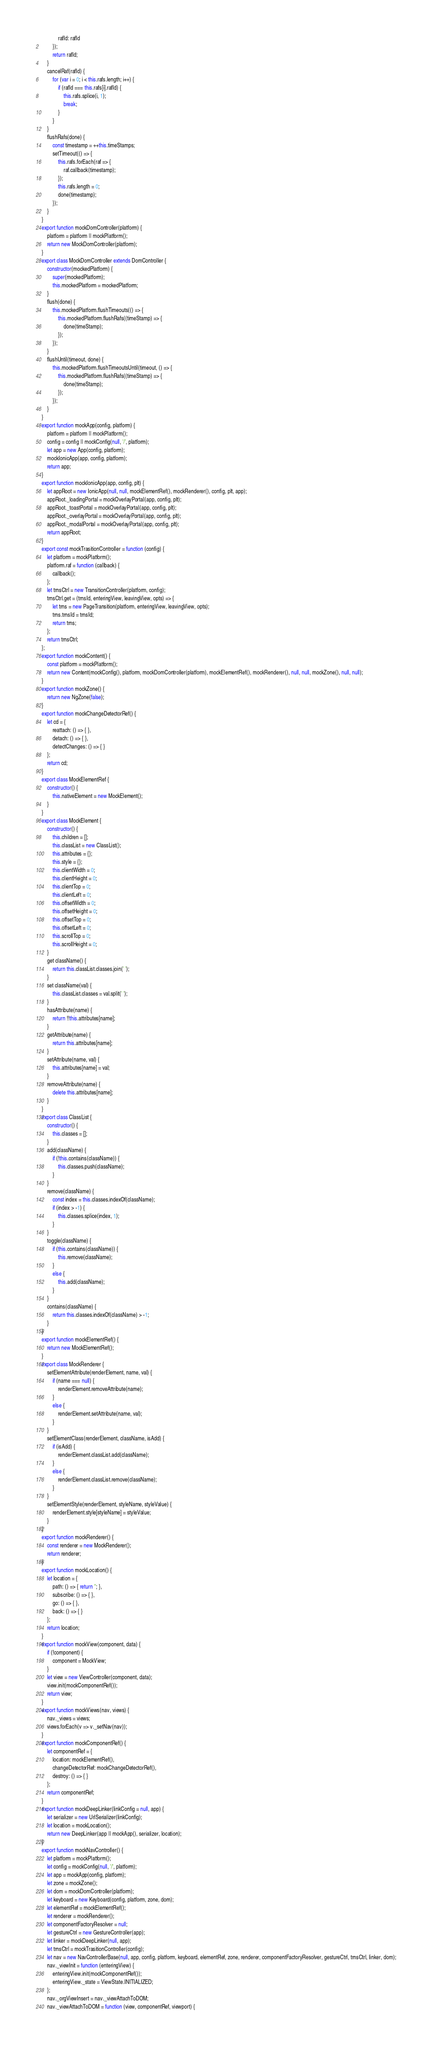<code> <loc_0><loc_0><loc_500><loc_500><_JavaScript_>            rafId: rafId
        });
        return rafId;
    }
    cancelRaf(rafId) {
        for (var i = 0; i < this.rafs.length; i++) {
            if (rafId === this.rafs[i].rafId) {
                this.rafs.splice(i, 1);
                break;
            }
        }
    }
    flushRafs(done) {
        const timestamp = ++this.timeStamps;
        setTimeout(() => {
            this.rafs.forEach(raf => {
                raf.callback(timestamp);
            });
            this.rafs.length = 0;
            done(timestamp);
        });
    }
}
export function mockDomController(platform) {
    platform = platform || mockPlatform();
    return new MockDomController(platform);
}
export class MockDomController extends DomController {
    constructor(mockedPlatform) {
        super(mockedPlatform);
        this.mockedPlatform = mockedPlatform;
    }
    flush(done) {
        this.mockedPlatform.flushTimeouts(() => {
            this.mockedPlatform.flushRafs((timeStamp) => {
                done(timeStamp);
            });
        });
    }
    flushUntil(timeout, done) {
        this.mockedPlatform.flushTimeoutsUntil(timeout, () => {
            this.mockedPlatform.flushRafs((timeStamp) => {
                done(timeStamp);
            });
        });
    }
}
export function mockApp(config, platform) {
    platform = platform || mockPlatform();
    config = config || mockConfig(null, '/', platform);
    let app = new App(config, platform);
    mockIonicApp(app, config, platform);
    return app;
}
export function mockIonicApp(app, config, plt) {
    let appRoot = new IonicApp(null, null, mockElementRef(), mockRenderer(), config, plt, app);
    appRoot._loadingPortal = mockOverlayPortal(app, config, plt);
    appRoot._toastPortal = mockOverlayPortal(app, config, plt);
    appRoot._overlayPortal = mockOverlayPortal(app, config, plt);
    appRoot._modalPortal = mockOverlayPortal(app, config, plt);
    return appRoot;
}
export const mockTrasitionController = function (config) {
    let platform = mockPlatform();
    platform.raf = function (callback) {
        callback();
    };
    let trnsCtrl = new TransitionController(platform, config);
    trnsCtrl.get = (trnsId, enteringView, leavingView, opts) => {
        let trns = new PageTransition(platform, enteringView, leavingView, opts);
        trns.trnsId = trnsId;
        return trns;
    };
    return trnsCtrl;
};
export function mockContent() {
    const platform = mockPlatform();
    return new Content(mockConfig(), platform, mockDomController(platform), mockElementRef(), mockRenderer(), null, null, mockZone(), null, null);
}
export function mockZone() {
    return new NgZone(false);
}
export function mockChangeDetectorRef() {
    let cd = {
        reattach: () => { },
        detach: () => { },
        detectChanges: () => { }
    };
    return cd;
}
export class MockElementRef {
    constructor() {
        this.nativeElement = new MockElement();
    }
}
export class MockElement {
    constructor() {
        this.children = [];
        this.classList = new ClassList();
        this.attributes = {};
        this.style = {};
        this.clientWidth = 0;
        this.clientHeight = 0;
        this.clientTop = 0;
        this.clientLeft = 0;
        this.offsetWidth = 0;
        this.offsetHeight = 0;
        this.offsetTop = 0;
        this.offsetLeft = 0;
        this.scrollTop = 0;
        this.scrollHeight = 0;
    }
    get className() {
        return this.classList.classes.join(' ');
    }
    set className(val) {
        this.classList.classes = val.split(' ');
    }
    hasAttribute(name) {
        return !!this.attributes[name];
    }
    getAttribute(name) {
        return this.attributes[name];
    }
    setAttribute(name, val) {
        this.attributes[name] = val;
    }
    removeAttribute(name) {
        delete this.attributes[name];
    }
}
export class ClassList {
    constructor() {
        this.classes = [];
    }
    add(className) {
        if (!this.contains(className)) {
            this.classes.push(className);
        }
    }
    remove(className) {
        const index = this.classes.indexOf(className);
        if (index > -1) {
            this.classes.splice(index, 1);
        }
    }
    toggle(className) {
        if (this.contains(className)) {
            this.remove(className);
        }
        else {
            this.add(className);
        }
    }
    contains(className) {
        return this.classes.indexOf(className) > -1;
    }
}
export function mockElementRef() {
    return new MockElementRef();
}
export class MockRenderer {
    setElementAttribute(renderElement, name, val) {
        if (name === null) {
            renderElement.removeAttribute(name);
        }
        else {
            renderElement.setAttribute(name, val);
        }
    }
    setElementClass(renderElement, className, isAdd) {
        if (isAdd) {
            renderElement.classList.add(className);
        }
        else {
            renderElement.classList.remove(className);
        }
    }
    setElementStyle(renderElement, styleName, styleValue) {
        renderElement.style[styleName] = styleValue;
    }
}
export function mockRenderer() {
    const renderer = new MockRenderer();
    return renderer;
}
export function mockLocation() {
    let location = {
        path: () => { return ''; },
        subscribe: () => { },
        go: () => { },
        back: () => { }
    };
    return location;
}
export function mockView(component, data) {
    if (!component) {
        component = MockView;
    }
    let view = new ViewController(component, data);
    view.init(mockComponentRef());
    return view;
}
export function mockViews(nav, views) {
    nav._views = views;
    views.forEach(v => v._setNav(nav));
}
export function mockComponentRef() {
    let componentRef = {
        location: mockElementRef(),
        changeDetectorRef: mockChangeDetectorRef(),
        destroy: () => { }
    };
    return componentRef;
}
export function mockDeepLinker(linkConfig = null, app) {
    let serializer = new UrlSerializer(linkConfig);
    let location = mockLocation();
    return new DeepLinker(app || mockApp(), serializer, location);
}
export function mockNavController() {
    let platform = mockPlatform();
    let config = mockConfig(null, '/', platform);
    let app = mockApp(config, platform);
    let zone = mockZone();
    let dom = mockDomController(platform);
    let keyboard = new Keyboard(config, platform, zone, dom);
    let elementRef = mockElementRef();
    let renderer = mockRenderer();
    let componentFactoryResolver = null;
    let gestureCtrl = new GestureController(app);
    let linker = mockDeepLinker(null, app);
    let trnsCtrl = mockTrasitionController(config);
    let nav = new NavControllerBase(null, app, config, platform, keyboard, elementRef, zone, renderer, componentFactoryResolver, gestureCtrl, trnsCtrl, linker, dom);
    nav._viewInit = function (enteringView) {
        enteringView.init(mockComponentRef());
        enteringView._state = ViewState.INITIALIZED;
    };
    nav._orgViewInsert = nav._viewAttachToDOM;
    nav._viewAttachToDOM = function (view, componentRef, viewport) {</code> 